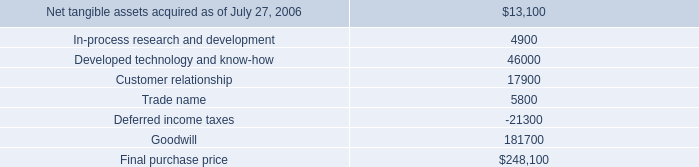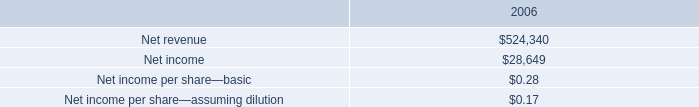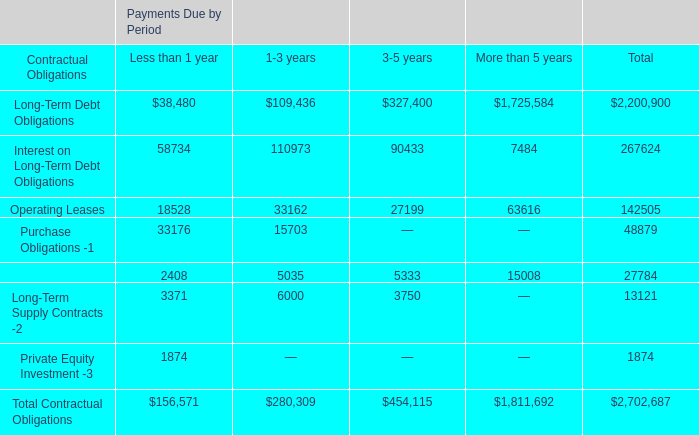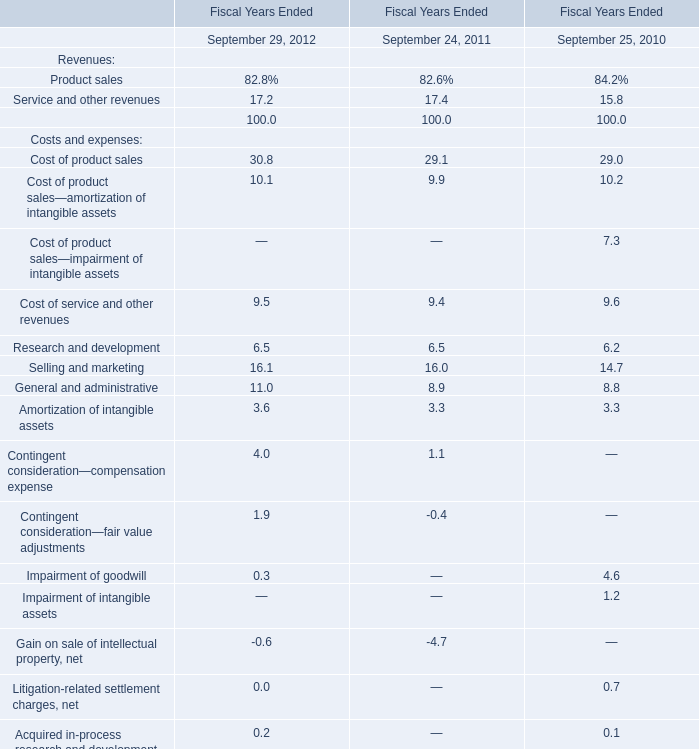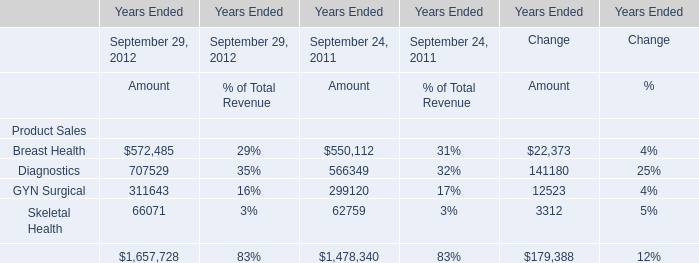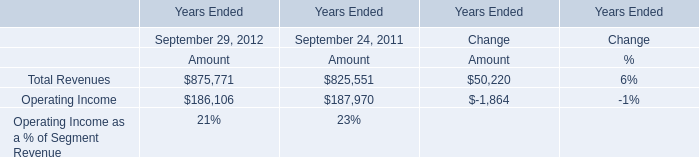What is the growing rate of GYN Surgical in the year with the most Diagnostics? 
Computations: ((311643 - 299120) / 299120)
Answer: 0.04187. 